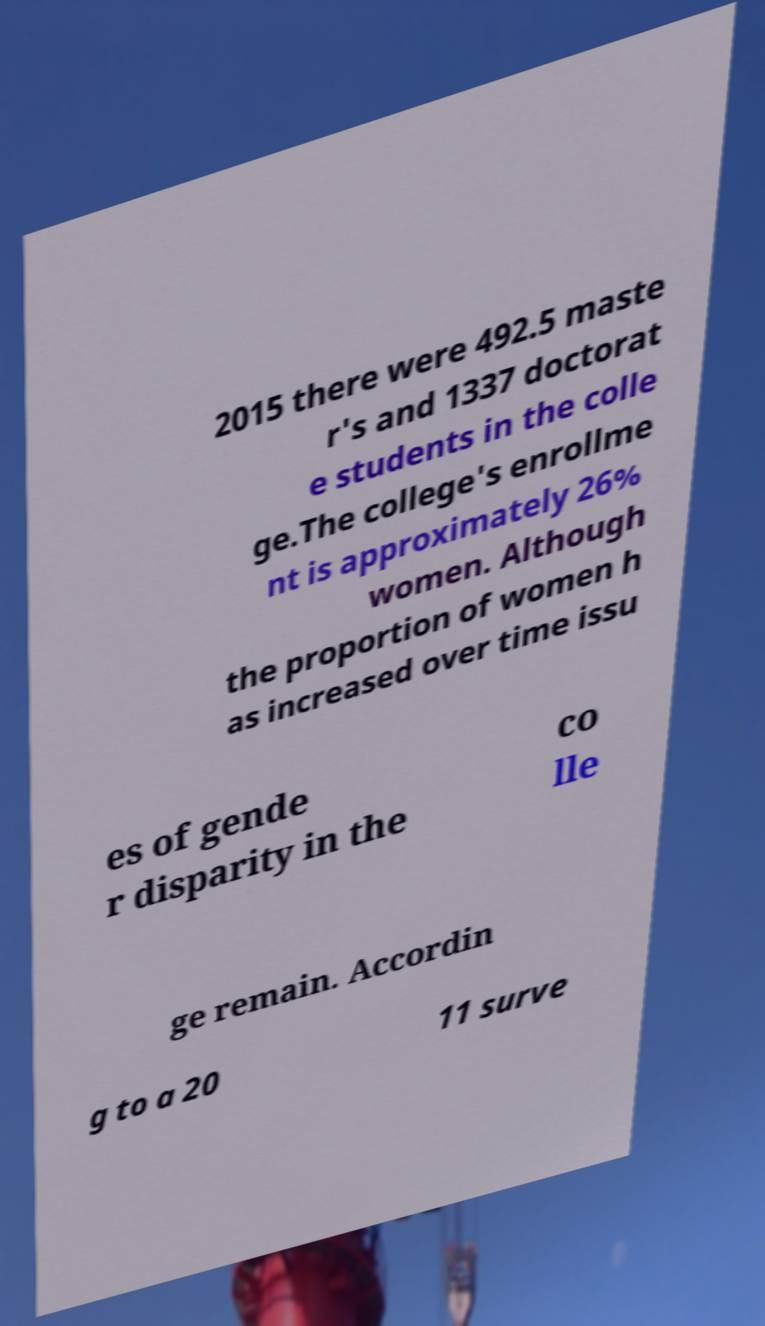I need the written content from this picture converted into text. Can you do that? 2015 there were 492.5 maste r's and 1337 doctorat e students in the colle ge.The college's enrollme nt is approximately 26% women. Although the proportion of women h as increased over time issu es of gende r disparity in the co lle ge remain. Accordin g to a 20 11 surve 